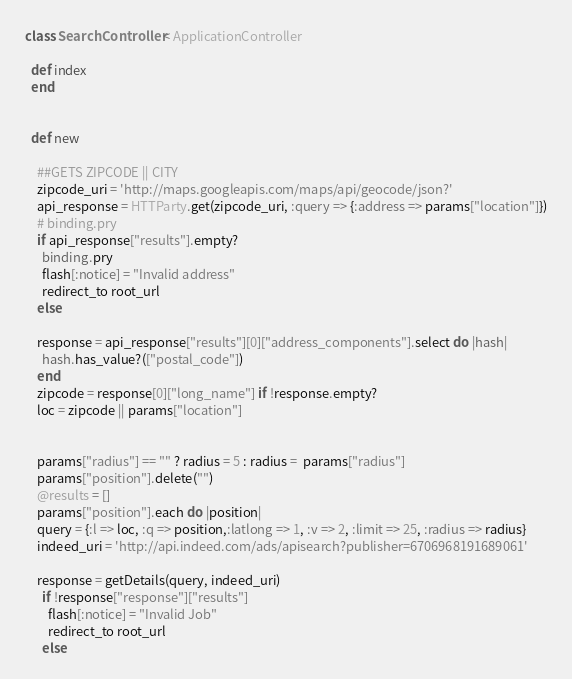<code> <loc_0><loc_0><loc_500><loc_500><_Ruby_>class SearchController < ApplicationController

  def index
  end


  def new

    ##GETS ZIPCODE || CITY
    zipcode_uri = 'http://maps.googleapis.com/maps/api/geocode/json?'
    api_response = HTTParty.get(zipcode_uri, :query => {:address => params["location"]})
    # binding.pry
    if api_response["results"].empty?
      binding.pry
      flash[:notice] = "Invalid address"
      redirect_to root_url
    else

    response = api_response["results"][0]["address_components"].select do |hash|
      hash.has_value?(["postal_code"])
    end
    zipcode = response[0]["long_name"] if !response.empty?
    loc = zipcode || params["location"]


    params["radius"] == "" ? radius = 5 : radius =  params["radius"]
    params["position"].delete("")
    @results = []
    params["position"].each do |position|
    query = {:l => loc, :q => position,:latlong => 1, :v => 2, :limit => 25, :radius => radius}
    indeed_uri = 'http://api.indeed.com/ads/apisearch?publisher=6706968191689061'

    response = getDetails(query, indeed_uri)
      if !response["response"]["results"]
        flash[:notice] = "Invalid Job"
        redirect_to root_url
      else</code> 